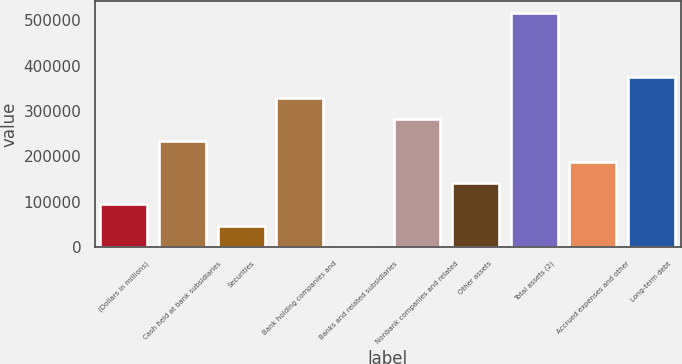Convert chart to OTSL. <chart><loc_0><loc_0><loc_500><loc_500><bar_chart><fcel>(Dollars in millions)<fcel>Cash held at bank subsidiaries<fcel>Securities<fcel>Bank holding companies and<fcel>Banks and related subsidiaries<fcel>Nonbank companies and related<fcel>Other assets<fcel>Total assets (2)<fcel>Accrued expenses and other<fcel>Long-term debt<nl><fcel>94109.4<fcel>235017<fcel>47140.2<fcel>328955<fcel>171<fcel>281986<fcel>141079<fcel>516832<fcel>188048<fcel>375925<nl></chart> 